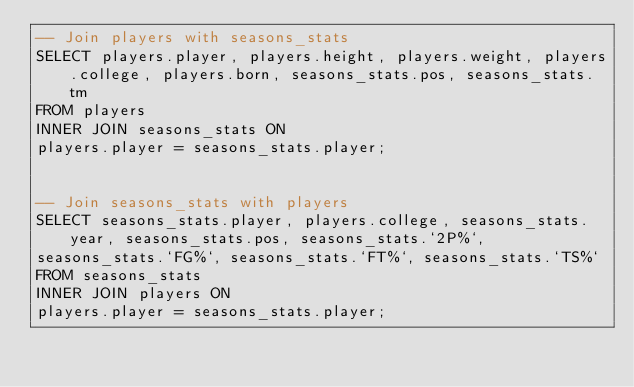Convert code to text. <code><loc_0><loc_0><loc_500><loc_500><_SQL_>-- Join players with seasons_stats
SELECT players.player, players.height, players.weight, players.college, players.born, seasons_stats.pos, seasons_stats.tm
FROM players
INNER JOIN seasons_stats ON
players.player = seasons_stats.player;


-- Join seasons_stats with players
SELECT seasons_stats.player, players.college, seasons_stats.year, seasons_stats.pos, seasons_stats.`2P%`,
seasons_stats.`FG%`, seasons_stats.`FT%`, seasons_stats.`TS%`
FROM seasons_stats
INNER JOIN players ON
players.player = seasons_stats.player;
</code> 